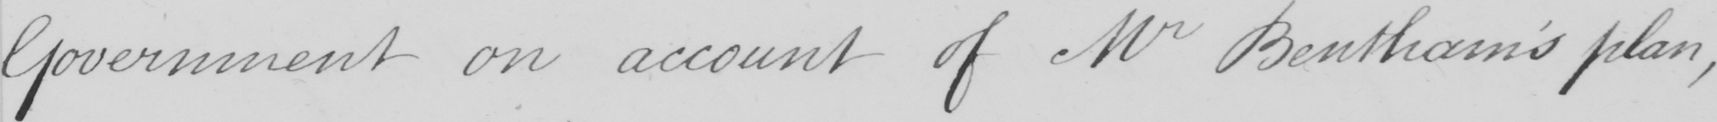What is written in this line of handwriting? Government on account of Mr Bentham ' s plan , 